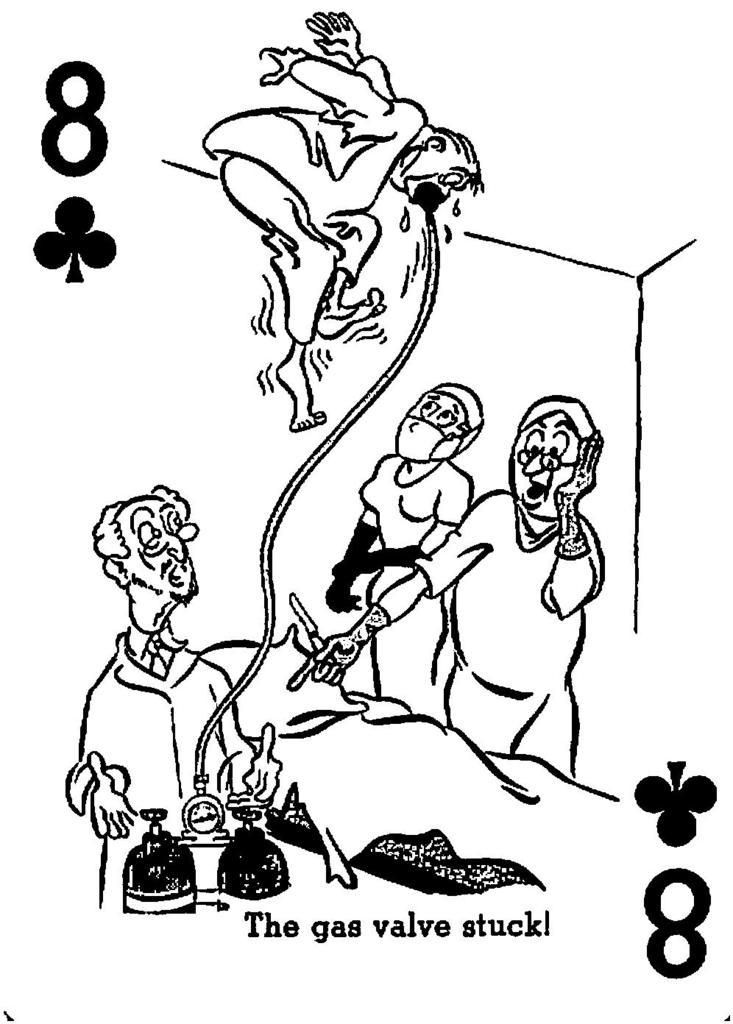What type of art is shown in the image? The art in the image depicts a scene with people standing around a bed. What is unusual about the patient in the art? The patient in the art appears to be floating or levitating in the air. What type of jam is being spread on the toast by the fireman in the image? There is no fireman or toast present in the image; it only features art depicting a scene with people standing around a bed. 